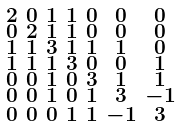<formula> <loc_0><loc_0><loc_500><loc_500>\begin{smallmatrix} 2 & 0 & 1 & 1 & 0 & 0 & 0 \\ 0 & 2 & 1 & 1 & 0 & 0 & 0 \\ 1 & 1 & 3 & 1 & 1 & 1 & 0 \\ 1 & 1 & 1 & 3 & 0 & 0 & 1 \\ 0 & 0 & 1 & 0 & 3 & 1 & 1 \\ 0 & 0 & 1 & 0 & 1 & 3 & - 1 \\ 0 & 0 & 0 & 1 & 1 & - 1 & 3 \end{smallmatrix}</formula> 